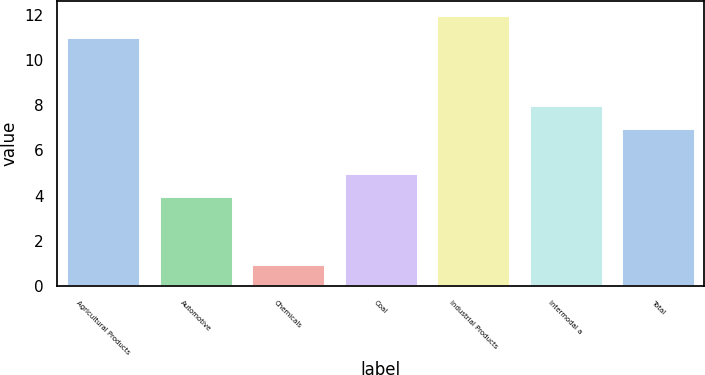<chart> <loc_0><loc_0><loc_500><loc_500><bar_chart><fcel>Agricultural Products<fcel>Automotive<fcel>Chemicals<fcel>Coal<fcel>Industrial Products<fcel>Intermodal a<fcel>Total<nl><fcel>11<fcel>4<fcel>1<fcel>5<fcel>12<fcel>8<fcel>7<nl></chart> 